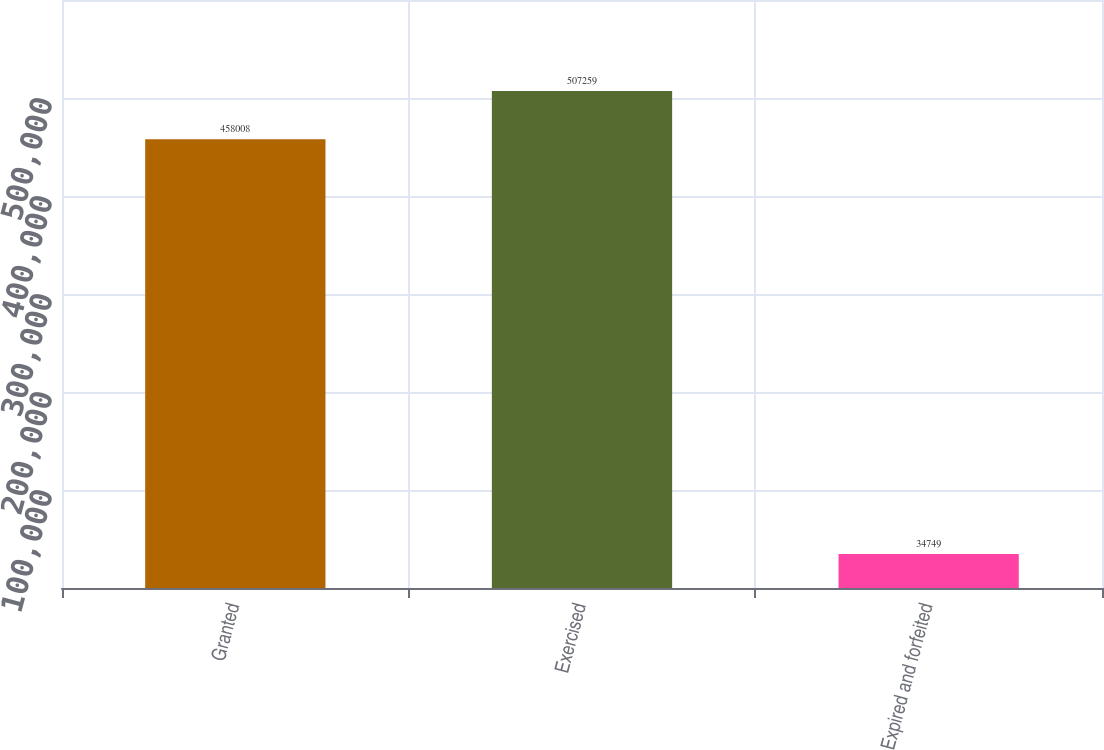<chart> <loc_0><loc_0><loc_500><loc_500><bar_chart><fcel>Granted<fcel>Exercised<fcel>Expired and forfeited<nl><fcel>458008<fcel>507259<fcel>34749<nl></chart> 